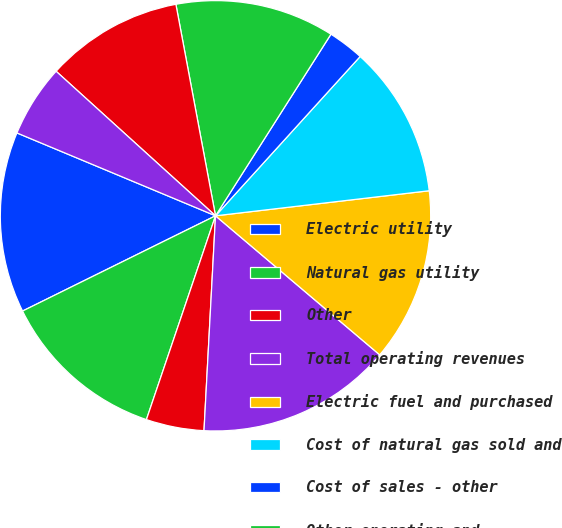Convert chart. <chart><loc_0><loc_0><loc_500><loc_500><pie_chart><fcel>Electric utility<fcel>Natural gas utility<fcel>Other<fcel>Total operating revenues<fcel>Electric fuel and purchased<fcel>Cost of natural gas sold and<fcel>Cost of sales - other<fcel>Other operating and<fcel>Depreciation and amortization<fcel>Taxes (other than income<nl><fcel>13.59%<fcel>12.5%<fcel>4.35%<fcel>14.67%<fcel>13.04%<fcel>11.41%<fcel>2.72%<fcel>11.96%<fcel>10.33%<fcel>5.43%<nl></chart> 